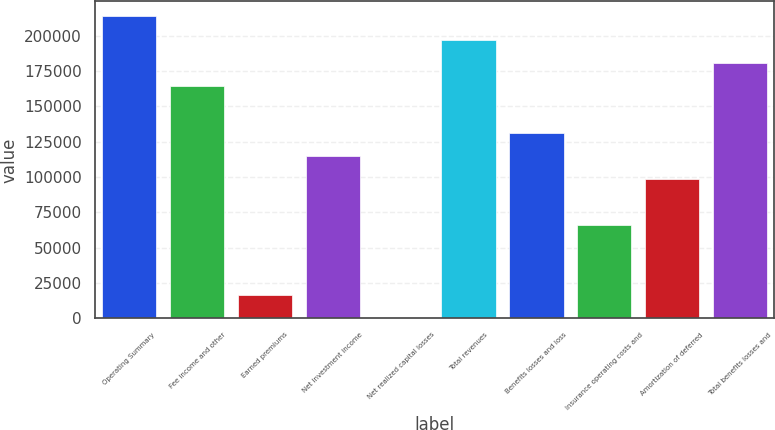<chart> <loc_0><loc_0><loc_500><loc_500><bar_chart><fcel>Operating Summary<fcel>Fee income and other<fcel>Earned premiums<fcel>Net investment income<fcel>Net realized capital losses<fcel>Total revenues<fcel>Benefits losses and loss<fcel>Insurance operating costs and<fcel>Amortization of deferred<fcel>Total benefits losses and<nl><fcel>213488<fcel>164227<fcel>16445.2<fcel>114966<fcel>25<fcel>197067<fcel>131387<fcel>65705.8<fcel>98546.2<fcel>180647<nl></chart> 